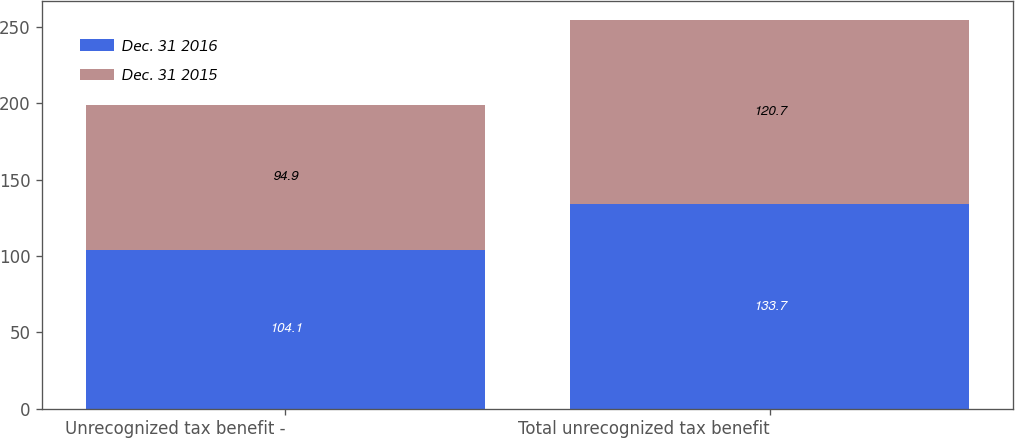Convert chart. <chart><loc_0><loc_0><loc_500><loc_500><stacked_bar_chart><ecel><fcel>Unrecognized tax benefit -<fcel>Total unrecognized tax benefit<nl><fcel>Dec. 31 2016<fcel>104.1<fcel>133.7<nl><fcel>Dec. 31 2015<fcel>94.9<fcel>120.7<nl></chart> 